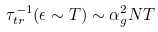<formula> <loc_0><loc_0><loc_500><loc_500>\tau ^ { - 1 } _ { t r } ( \epsilon \sim T ) \sim \alpha _ { g } ^ { 2 } N T</formula> 